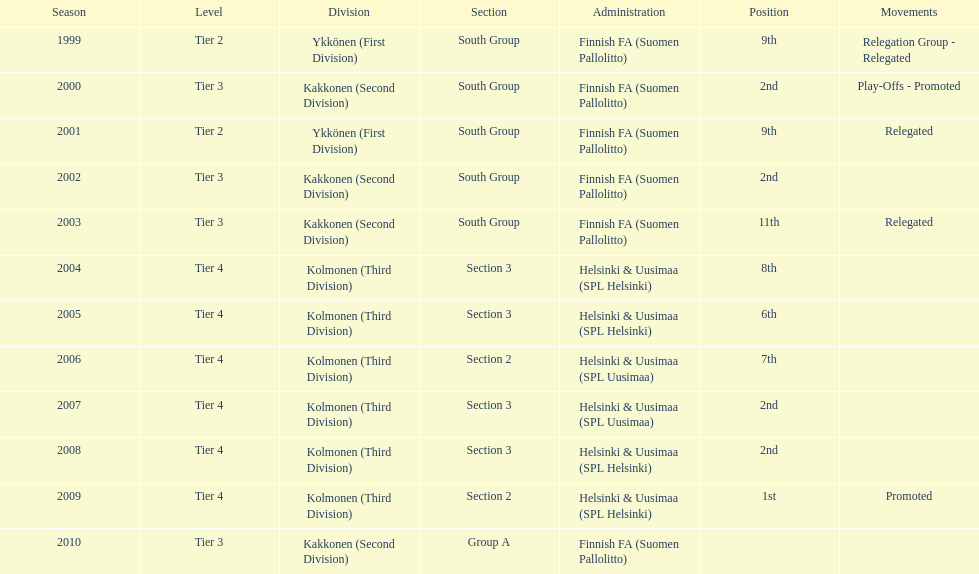What is the number of successive instances they participated in tier 4? 6. 